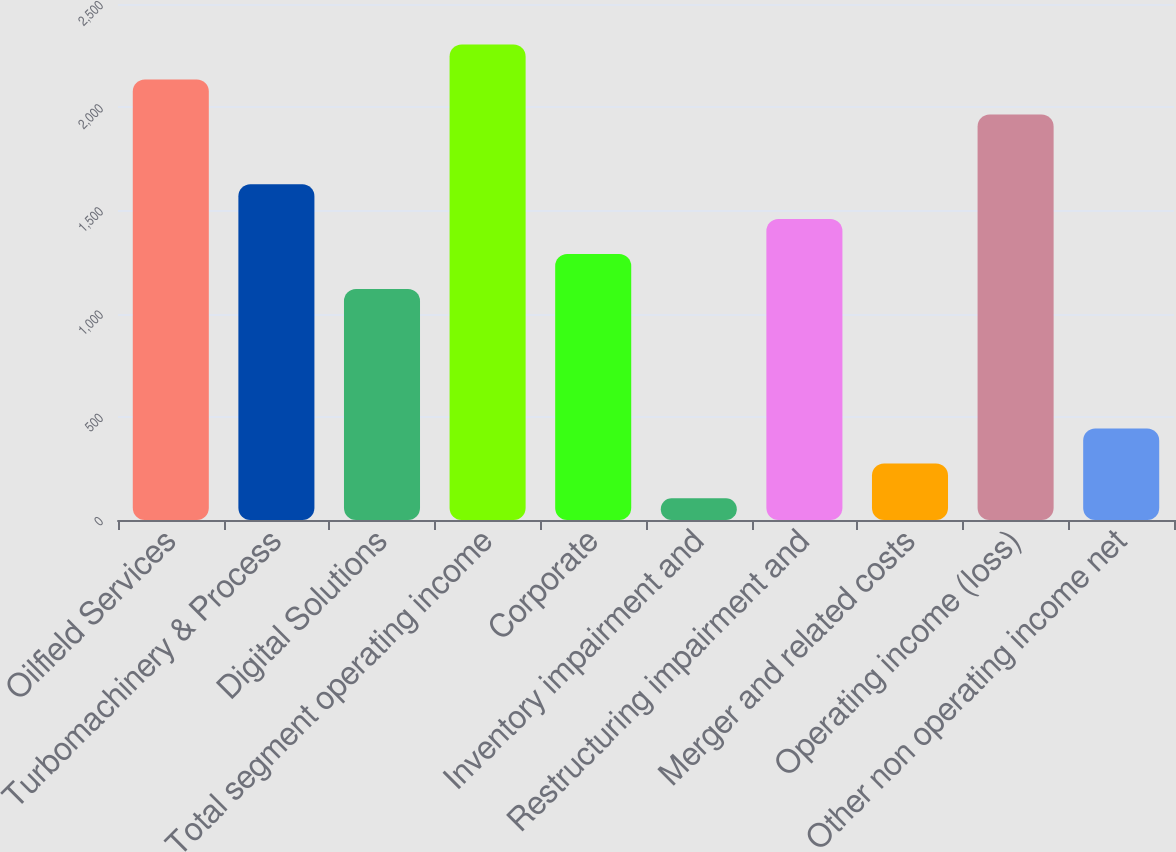<chart> <loc_0><loc_0><loc_500><loc_500><bar_chart><fcel>Oilfield Services<fcel>Turbomachinery & Process<fcel>Digital Solutions<fcel>Total segment operating income<fcel>Corporate<fcel>Inventory impairment and<fcel>Restructuring impairment and<fcel>Merger and related costs<fcel>Operating income (loss)<fcel>Other non operating income net<nl><fcel>2134.2<fcel>1626.9<fcel>1119.6<fcel>2303.3<fcel>1288.7<fcel>105<fcel>1457.8<fcel>274.1<fcel>1965.1<fcel>443.2<nl></chart> 